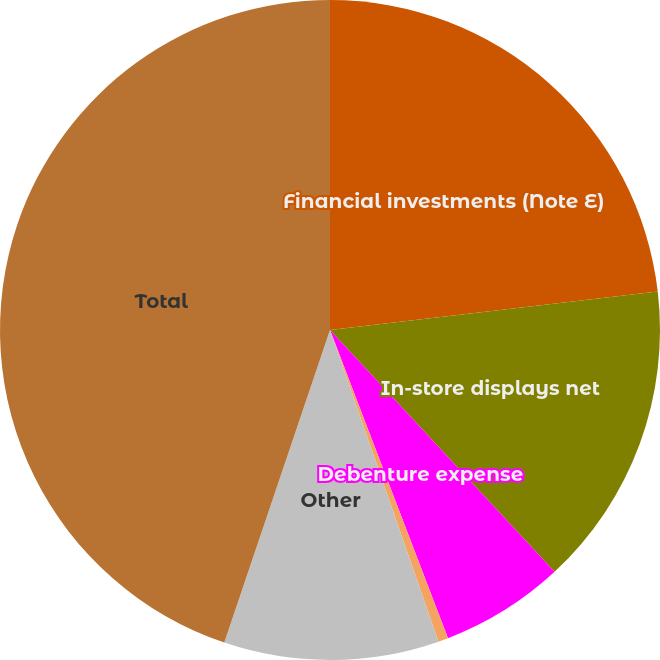Convert chart to OTSL. <chart><loc_0><loc_0><loc_500><loc_500><pie_chart><fcel>Financial investments (Note E)<fcel>In-store displays net<fcel>Debenture expense<fcel>Notes receivable<fcel>Other<fcel>Total<nl><fcel>23.14%<fcel>14.95%<fcel>6.09%<fcel>0.49%<fcel>10.52%<fcel>44.81%<nl></chart> 